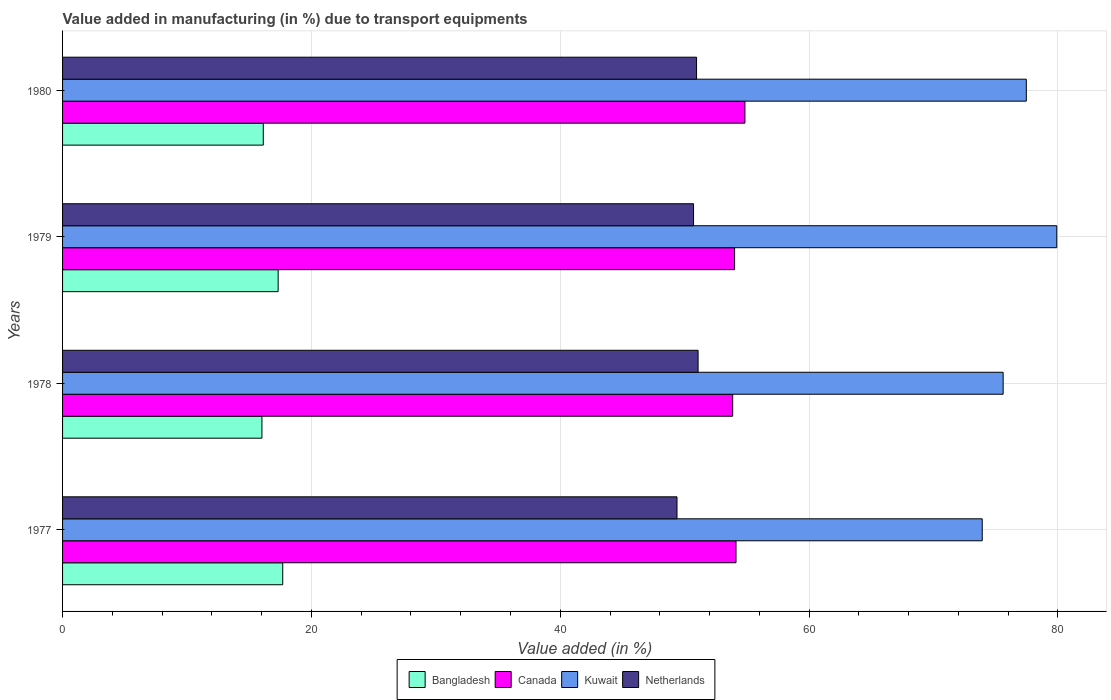How many different coloured bars are there?
Make the answer very short. 4. What is the label of the 4th group of bars from the top?
Keep it short and to the point. 1977. In how many cases, is the number of bars for a given year not equal to the number of legend labels?
Your answer should be compact. 0. What is the percentage of value added in manufacturing due to transport equipments in Kuwait in 1979?
Provide a short and direct response. 79.91. Across all years, what is the maximum percentage of value added in manufacturing due to transport equipments in Kuwait?
Your answer should be compact. 79.91. Across all years, what is the minimum percentage of value added in manufacturing due to transport equipments in Netherlands?
Your answer should be very brief. 49.38. In which year was the percentage of value added in manufacturing due to transport equipments in Netherlands minimum?
Make the answer very short. 1977. What is the total percentage of value added in manufacturing due to transport equipments in Kuwait in the graph?
Give a very brief answer. 306.88. What is the difference between the percentage of value added in manufacturing due to transport equipments in Kuwait in 1978 and that in 1979?
Provide a succinct answer. -4.31. What is the difference between the percentage of value added in manufacturing due to transport equipments in Kuwait in 1979 and the percentage of value added in manufacturing due to transport equipments in Netherlands in 1977?
Make the answer very short. 30.52. What is the average percentage of value added in manufacturing due to transport equipments in Canada per year?
Your answer should be compact. 54.21. In the year 1977, what is the difference between the percentage of value added in manufacturing due to transport equipments in Bangladesh and percentage of value added in manufacturing due to transport equipments in Canada?
Offer a very short reply. -36.43. In how many years, is the percentage of value added in manufacturing due to transport equipments in Canada greater than 76 %?
Offer a terse response. 0. What is the ratio of the percentage of value added in manufacturing due to transport equipments in Canada in 1978 to that in 1980?
Provide a short and direct response. 0.98. What is the difference between the highest and the second highest percentage of value added in manufacturing due to transport equipments in Canada?
Ensure brevity in your answer.  0.72. What is the difference between the highest and the lowest percentage of value added in manufacturing due to transport equipments in Canada?
Your answer should be compact. 0.98. Is the sum of the percentage of value added in manufacturing due to transport equipments in Kuwait in 1977 and 1978 greater than the maximum percentage of value added in manufacturing due to transport equipments in Netherlands across all years?
Give a very brief answer. Yes. What does the 1st bar from the bottom in 1977 represents?
Offer a very short reply. Bangladesh. Is it the case that in every year, the sum of the percentage of value added in manufacturing due to transport equipments in Netherlands and percentage of value added in manufacturing due to transport equipments in Bangladesh is greater than the percentage of value added in manufacturing due to transport equipments in Canada?
Your answer should be very brief. Yes. How many bars are there?
Your answer should be very brief. 16. What is the difference between two consecutive major ticks on the X-axis?
Offer a very short reply. 20. What is the title of the graph?
Offer a terse response. Value added in manufacturing (in %) due to transport equipments. What is the label or title of the X-axis?
Make the answer very short. Value added (in %). What is the label or title of the Y-axis?
Make the answer very short. Years. What is the Value added (in %) of Bangladesh in 1977?
Offer a terse response. 17.7. What is the Value added (in %) in Canada in 1977?
Give a very brief answer. 54.13. What is the Value added (in %) of Kuwait in 1977?
Offer a very short reply. 73.92. What is the Value added (in %) of Netherlands in 1977?
Keep it short and to the point. 49.38. What is the Value added (in %) in Bangladesh in 1978?
Provide a succinct answer. 16.02. What is the Value added (in %) of Canada in 1978?
Your response must be concise. 53.86. What is the Value added (in %) of Kuwait in 1978?
Your answer should be very brief. 75.6. What is the Value added (in %) in Netherlands in 1978?
Your answer should be compact. 51.08. What is the Value added (in %) of Bangladesh in 1979?
Offer a terse response. 17.33. What is the Value added (in %) of Canada in 1979?
Keep it short and to the point. 54.01. What is the Value added (in %) in Kuwait in 1979?
Offer a very short reply. 79.91. What is the Value added (in %) of Netherlands in 1979?
Your answer should be very brief. 50.71. What is the Value added (in %) of Bangladesh in 1980?
Your answer should be very brief. 16.13. What is the Value added (in %) of Canada in 1980?
Ensure brevity in your answer.  54.84. What is the Value added (in %) of Kuwait in 1980?
Keep it short and to the point. 77.46. What is the Value added (in %) in Netherlands in 1980?
Your answer should be very brief. 50.96. Across all years, what is the maximum Value added (in %) in Bangladesh?
Make the answer very short. 17.7. Across all years, what is the maximum Value added (in %) in Canada?
Make the answer very short. 54.84. Across all years, what is the maximum Value added (in %) in Kuwait?
Provide a short and direct response. 79.91. Across all years, what is the maximum Value added (in %) of Netherlands?
Give a very brief answer. 51.08. Across all years, what is the minimum Value added (in %) in Bangladesh?
Give a very brief answer. 16.02. Across all years, what is the minimum Value added (in %) in Canada?
Ensure brevity in your answer.  53.86. Across all years, what is the minimum Value added (in %) of Kuwait?
Provide a succinct answer. 73.92. Across all years, what is the minimum Value added (in %) of Netherlands?
Keep it short and to the point. 49.38. What is the total Value added (in %) of Bangladesh in the graph?
Your response must be concise. 67.18. What is the total Value added (in %) of Canada in the graph?
Your answer should be compact. 216.84. What is the total Value added (in %) in Kuwait in the graph?
Make the answer very short. 306.88. What is the total Value added (in %) of Netherlands in the graph?
Give a very brief answer. 202.13. What is the difference between the Value added (in %) in Bangladesh in 1977 and that in 1978?
Provide a short and direct response. 1.67. What is the difference between the Value added (in %) in Canada in 1977 and that in 1978?
Your answer should be very brief. 0.27. What is the difference between the Value added (in %) of Kuwait in 1977 and that in 1978?
Ensure brevity in your answer.  -1.68. What is the difference between the Value added (in %) of Netherlands in 1977 and that in 1978?
Keep it short and to the point. -1.7. What is the difference between the Value added (in %) of Bangladesh in 1977 and that in 1979?
Offer a terse response. 0.37. What is the difference between the Value added (in %) of Canada in 1977 and that in 1979?
Keep it short and to the point. 0.11. What is the difference between the Value added (in %) in Kuwait in 1977 and that in 1979?
Make the answer very short. -5.99. What is the difference between the Value added (in %) in Netherlands in 1977 and that in 1979?
Your response must be concise. -1.33. What is the difference between the Value added (in %) of Bangladesh in 1977 and that in 1980?
Your response must be concise. 1.56. What is the difference between the Value added (in %) in Canada in 1977 and that in 1980?
Provide a succinct answer. -0.72. What is the difference between the Value added (in %) of Kuwait in 1977 and that in 1980?
Offer a terse response. -3.54. What is the difference between the Value added (in %) of Netherlands in 1977 and that in 1980?
Provide a succinct answer. -1.57. What is the difference between the Value added (in %) in Bangladesh in 1978 and that in 1979?
Make the answer very short. -1.3. What is the difference between the Value added (in %) of Canada in 1978 and that in 1979?
Provide a short and direct response. -0.15. What is the difference between the Value added (in %) of Kuwait in 1978 and that in 1979?
Ensure brevity in your answer.  -4.31. What is the difference between the Value added (in %) of Netherlands in 1978 and that in 1979?
Make the answer very short. 0.37. What is the difference between the Value added (in %) in Bangladesh in 1978 and that in 1980?
Offer a very short reply. -0.11. What is the difference between the Value added (in %) in Canada in 1978 and that in 1980?
Your answer should be very brief. -0.98. What is the difference between the Value added (in %) in Kuwait in 1978 and that in 1980?
Provide a short and direct response. -1.86. What is the difference between the Value added (in %) of Netherlands in 1978 and that in 1980?
Offer a terse response. 0.12. What is the difference between the Value added (in %) in Bangladesh in 1979 and that in 1980?
Your answer should be compact. 1.2. What is the difference between the Value added (in %) in Canada in 1979 and that in 1980?
Your answer should be very brief. -0.83. What is the difference between the Value added (in %) in Kuwait in 1979 and that in 1980?
Your answer should be compact. 2.45. What is the difference between the Value added (in %) in Netherlands in 1979 and that in 1980?
Keep it short and to the point. -0.24. What is the difference between the Value added (in %) in Bangladesh in 1977 and the Value added (in %) in Canada in 1978?
Make the answer very short. -36.16. What is the difference between the Value added (in %) in Bangladesh in 1977 and the Value added (in %) in Kuwait in 1978?
Offer a very short reply. -57.9. What is the difference between the Value added (in %) in Bangladesh in 1977 and the Value added (in %) in Netherlands in 1978?
Offer a very short reply. -33.38. What is the difference between the Value added (in %) in Canada in 1977 and the Value added (in %) in Kuwait in 1978?
Your answer should be very brief. -21.47. What is the difference between the Value added (in %) in Canada in 1977 and the Value added (in %) in Netherlands in 1978?
Ensure brevity in your answer.  3.05. What is the difference between the Value added (in %) in Kuwait in 1977 and the Value added (in %) in Netherlands in 1978?
Provide a short and direct response. 22.84. What is the difference between the Value added (in %) of Bangladesh in 1977 and the Value added (in %) of Canada in 1979?
Your response must be concise. -36.32. What is the difference between the Value added (in %) of Bangladesh in 1977 and the Value added (in %) of Kuwait in 1979?
Offer a very short reply. -62.21. What is the difference between the Value added (in %) in Bangladesh in 1977 and the Value added (in %) in Netherlands in 1979?
Your answer should be very brief. -33.02. What is the difference between the Value added (in %) in Canada in 1977 and the Value added (in %) in Kuwait in 1979?
Make the answer very short. -25.78. What is the difference between the Value added (in %) in Canada in 1977 and the Value added (in %) in Netherlands in 1979?
Ensure brevity in your answer.  3.41. What is the difference between the Value added (in %) in Kuwait in 1977 and the Value added (in %) in Netherlands in 1979?
Your response must be concise. 23.2. What is the difference between the Value added (in %) of Bangladesh in 1977 and the Value added (in %) of Canada in 1980?
Provide a short and direct response. -37.15. What is the difference between the Value added (in %) in Bangladesh in 1977 and the Value added (in %) in Kuwait in 1980?
Your answer should be very brief. -59.76. What is the difference between the Value added (in %) in Bangladesh in 1977 and the Value added (in %) in Netherlands in 1980?
Provide a succinct answer. -33.26. What is the difference between the Value added (in %) in Canada in 1977 and the Value added (in %) in Kuwait in 1980?
Give a very brief answer. -23.33. What is the difference between the Value added (in %) of Canada in 1977 and the Value added (in %) of Netherlands in 1980?
Your answer should be very brief. 3.17. What is the difference between the Value added (in %) of Kuwait in 1977 and the Value added (in %) of Netherlands in 1980?
Make the answer very short. 22.96. What is the difference between the Value added (in %) of Bangladesh in 1978 and the Value added (in %) of Canada in 1979?
Ensure brevity in your answer.  -37.99. What is the difference between the Value added (in %) of Bangladesh in 1978 and the Value added (in %) of Kuwait in 1979?
Your answer should be very brief. -63.88. What is the difference between the Value added (in %) of Bangladesh in 1978 and the Value added (in %) of Netherlands in 1979?
Make the answer very short. -34.69. What is the difference between the Value added (in %) in Canada in 1978 and the Value added (in %) in Kuwait in 1979?
Your response must be concise. -26.05. What is the difference between the Value added (in %) in Canada in 1978 and the Value added (in %) in Netherlands in 1979?
Keep it short and to the point. 3.15. What is the difference between the Value added (in %) in Kuwait in 1978 and the Value added (in %) in Netherlands in 1979?
Offer a terse response. 24.88. What is the difference between the Value added (in %) in Bangladesh in 1978 and the Value added (in %) in Canada in 1980?
Your answer should be compact. -38.82. What is the difference between the Value added (in %) of Bangladesh in 1978 and the Value added (in %) of Kuwait in 1980?
Give a very brief answer. -61.43. What is the difference between the Value added (in %) of Bangladesh in 1978 and the Value added (in %) of Netherlands in 1980?
Your answer should be very brief. -34.93. What is the difference between the Value added (in %) of Canada in 1978 and the Value added (in %) of Kuwait in 1980?
Offer a terse response. -23.6. What is the difference between the Value added (in %) of Canada in 1978 and the Value added (in %) of Netherlands in 1980?
Ensure brevity in your answer.  2.9. What is the difference between the Value added (in %) in Kuwait in 1978 and the Value added (in %) in Netherlands in 1980?
Provide a short and direct response. 24.64. What is the difference between the Value added (in %) of Bangladesh in 1979 and the Value added (in %) of Canada in 1980?
Provide a short and direct response. -37.51. What is the difference between the Value added (in %) in Bangladesh in 1979 and the Value added (in %) in Kuwait in 1980?
Make the answer very short. -60.13. What is the difference between the Value added (in %) of Bangladesh in 1979 and the Value added (in %) of Netherlands in 1980?
Offer a terse response. -33.63. What is the difference between the Value added (in %) in Canada in 1979 and the Value added (in %) in Kuwait in 1980?
Make the answer very short. -23.45. What is the difference between the Value added (in %) in Canada in 1979 and the Value added (in %) in Netherlands in 1980?
Make the answer very short. 3.06. What is the difference between the Value added (in %) of Kuwait in 1979 and the Value added (in %) of Netherlands in 1980?
Provide a succinct answer. 28.95. What is the average Value added (in %) of Bangladesh per year?
Provide a succinct answer. 16.79. What is the average Value added (in %) in Canada per year?
Offer a very short reply. 54.21. What is the average Value added (in %) of Kuwait per year?
Ensure brevity in your answer.  76.72. What is the average Value added (in %) of Netherlands per year?
Provide a short and direct response. 50.53. In the year 1977, what is the difference between the Value added (in %) in Bangladesh and Value added (in %) in Canada?
Ensure brevity in your answer.  -36.43. In the year 1977, what is the difference between the Value added (in %) of Bangladesh and Value added (in %) of Kuwait?
Your answer should be compact. -56.22. In the year 1977, what is the difference between the Value added (in %) in Bangladesh and Value added (in %) in Netherlands?
Offer a very short reply. -31.69. In the year 1977, what is the difference between the Value added (in %) of Canada and Value added (in %) of Kuwait?
Your response must be concise. -19.79. In the year 1977, what is the difference between the Value added (in %) of Canada and Value added (in %) of Netherlands?
Give a very brief answer. 4.74. In the year 1977, what is the difference between the Value added (in %) of Kuwait and Value added (in %) of Netherlands?
Offer a very short reply. 24.53. In the year 1978, what is the difference between the Value added (in %) of Bangladesh and Value added (in %) of Canada?
Offer a terse response. -37.84. In the year 1978, what is the difference between the Value added (in %) of Bangladesh and Value added (in %) of Kuwait?
Make the answer very short. -59.57. In the year 1978, what is the difference between the Value added (in %) of Bangladesh and Value added (in %) of Netherlands?
Offer a terse response. -35.06. In the year 1978, what is the difference between the Value added (in %) of Canada and Value added (in %) of Kuwait?
Offer a very short reply. -21.74. In the year 1978, what is the difference between the Value added (in %) in Canada and Value added (in %) in Netherlands?
Your response must be concise. 2.78. In the year 1978, what is the difference between the Value added (in %) of Kuwait and Value added (in %) of Netherlands?
Offer a terse response. 24.52. In the year 1979, what is the difference between the Value added (in %) in Bangladesh and Value added (in %) in Canada?
Offer a very short reply. -36.68. In the year 1979, what is the difference between the Value added (in %) in Bangladesh and Value added (in %) in Kuwait?
Your response must be concise. -62.58. In the year 1979, what is the difference between the Value added (in %) of Bangladesh and Value added (in %) of Netherlands?
Your answer should be compact. -33.38. In the year 1979, what is the difference between the Value added (in %) in Canada and Value added (in %) in Kuwait?
Ensure brevity in your answer.  -25.9. In the year 1979, what is the difference between the Value added (in %) in Canada and Value added (in %) in Netherlands?
Give a very brief answer. 3.3. In the year 1979, what is the difference between the Value added (in %) in Kuwait and Value added (in %) in Netherlands?
Make the answer very short. 29.2. In the year 1980, what is the difference between the Value added (in %) of Bangladesh and Value added (in %) of Canada?
Your response must be concise. -38.71. In the year 1980, what is the difference between the Value added (in %) in Bangladesh and Value added (in %) in Kuwait?
Ensure brevity in your answer.  -61.33. In the year 1980, what is the difference between the Value added (in %) of Bangladesh and Value added (in %) of Netherlands?
Your response must be concise. -34.82. In the year 1980, what is the difference between the Value added (in %) of Canada and Value added (in %) of Kuwait?
Your answer should be compact. -22.62. In the year 1980, what is the difference between the Value added (in %) of Canada and Value added (in %) of Netherlands?
Provide a short and direct response. 3.89. In the year 1980, what is the difference between the Value added (in %) of Kuwait and Value added (in %) of Netherlands?
Make the answer very short. 26.5. What is the ratio of the Value added (in %) of Bangladesh in 1977 to that in 1978?
Ensure brevity in your answer.  1.1. What is the ratio of the Value added (in %) of Canada in 1977 to that in 1978?
Give a very brief answer. 1. What is the ratio of the Value added (in %) of Kuwait in 1977 to that in 1978?
Provide a succinct answer. 0.98. What is the ratio of the Value added (in %) of Netherlands in 1977 to that in 1978?
Give a very brief answer. 0.97. What is the ratio of the Value added (in %) in Bangladesh in 1977 to that in 1979?
Make the answer very short. 1.02. What is the ratio of the Value added (in %) in Canada in 1977 to that in 1979?
Provide a succinct answer. 1. What is the ratio of the Value added (in %) in Kuwait in 1977 to that in 1979?
Provide a succinct answer. 0.93. What is the ratio of the Value added (in %) in Netherlands in 1977 to that in 1979?
Provide a succinct answer. 0.97. What is the ratio of the Value added (in %) of Bangladesh in 1977 to that in 1980?
Keep it short and to the point. 1.1. What is the ratio of the Value added (in %) of Canada in 1977 to that in 1980?
Your answer should be very brief. 0.99. What is the ratio of the Value added (in %) of Kuwait in 1977 to that in 1980?
Make the answer very short. 0.95. What is the ratio of the Value added (in %) in Netherlands in 1977 to that in 1980?
Make the answer very short. 0.97. What is the ratio of the Value added (in %) of Bangladesh in 1978 to that in 1979?
Your response must be concise. 0.92. What is the ratio of the Value added (in %) in Kuwait in 1978 to that in 1979?
Offer a very short reply. 0.95. What is the ratio of the Value added (in %) of Netherlands in 1978 to that in 1979?
Keep it short and to the point. 1.01. What is the ratio of the Value added (in %) in Bangladesh in 1978 to that in 1980?
Provide a short and direct response. 0.99. What is the ratio of the Value added (in %) of Canada in 1978 to that in 1980?
Provide a short and direct response. 0.98. What is the ratio of the Value added (in %) of Kuwait in 1978 to that in 1980?
Provide a short and direct response. 0.98. What is the ratio of the Value added (in %) in Bangladesh in 1979 to that in 1980?
Provide a succinct answer. 1.07. What is the ratio of the Value added (in %) in Canada in 1979 to that in 1980?
Offer a terse response. 0.98. What is the ratio of the Value added (in %) in Kuwait in 1979 to that in 1980?
Give a very brief answer. 1.03. What is the ratio of the Value added (in %) of Netherlands in 1979 to that in 1980?
Provide a short and direct response. 1. What is the difference between the highest and the second highest Value added (in %) of Bangladesh?
Make the answer very short. 0.37. What is the difference between the highest and the second highest Value added (in %) in Canada?
Ensure brevity in your answer.  0.72. What is the difference between the highest and the second highest Value added (in %) in Kuwait?
Your answer should be very brief. 2.45. What is the difference between the highest and the second highest Value added (in %) of Netherlands?
Your answer should be very brief. 0.12. What is the difference between the highest and the lowest Value added (in %) of Bangladesh?
Offer a terse response. 1.67. What is the difference between the highest and the lowest Value added (in %) of Canada?
Make the answer very short. 0.98. What is the difference between the highest and the lowest Value added (in %) in Kuwait?
Ensure brevity in your answer.  5.99. What is the difference between the highest and the lowest Value added (in %) of Netherlands?
Your answer should be compact. 1.7. 